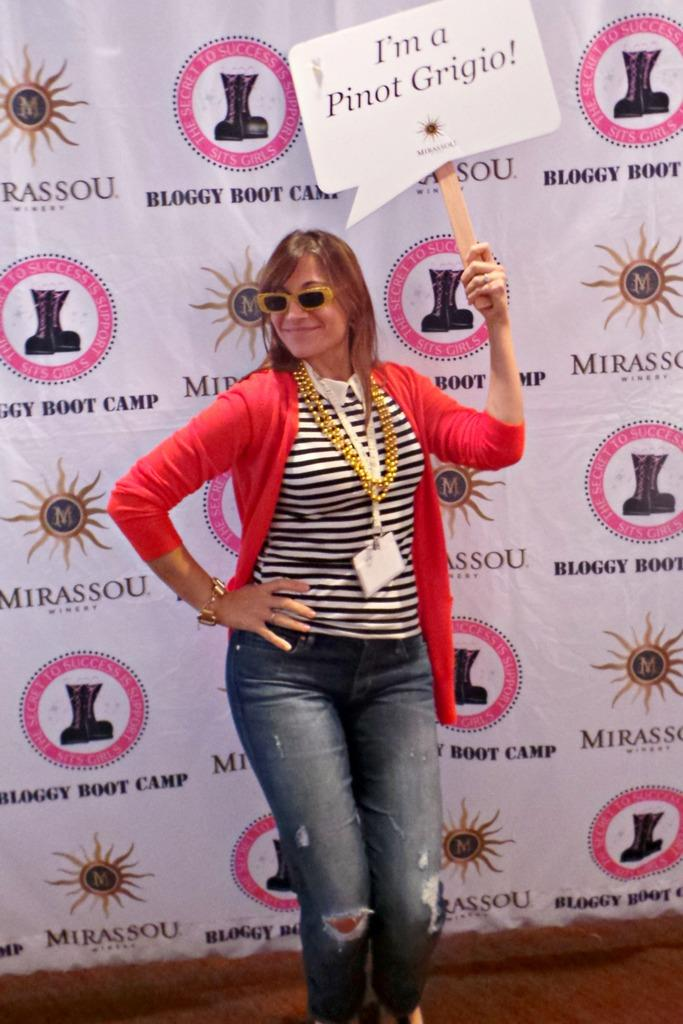What is the person in the image doing? The person is standing in the image and holding a board. What can be seen in the person's hands? The person is holding a board. What colors are present on the person's shirt? The person's shirt has red, white, and black colors. What is visible in the background of the image? There is a banner in the background of the image. What color is the banner? The banner is white in color. Can you see any glasses on the person's face in the image? There is no mention of glasses in the provided facts, so we cannot determine if the person is wearing any. 